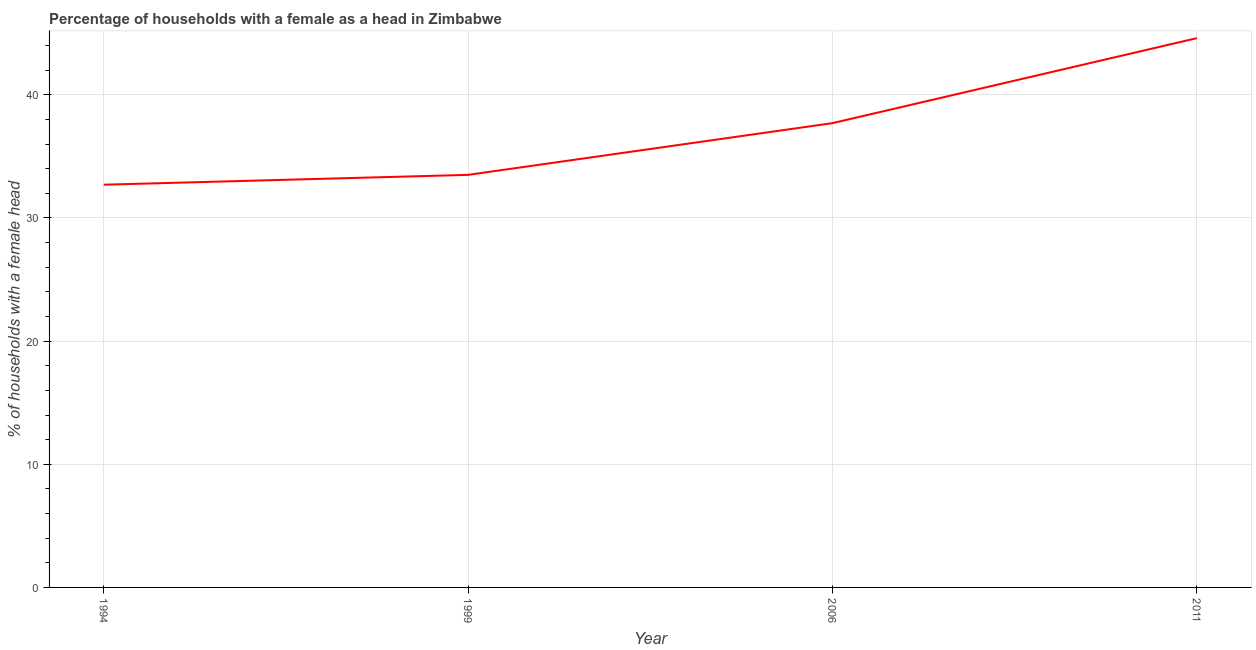What is the number of female supervised households in 2006?
Your answer should be very brief. 37.7. Across all years, what is the maximum number of female supervised households?
Provide a succinct answer. 44.6. Across all years, what is the minimum number of female supervised households?
Offer a very short reply. 32.7. In which year was the number of female supervised households maximum?
Provide a short and direct response. 2011. In which year was the number of female supervised households minimum?
Keep it short and to the point. 1994. What is the sum of the number of female supervised households?
Give a very brief answer. 148.5. What is the difference between the number of female supervised households in 1994 and 2011?
Provide a succinct answer. -11.9. What is the average number of female supervised households per year?
Make the answer very short. 37.12. What is the median number of female supervised households?
Ensure brevity in your answer.  35.6. What is the ratio of the number of female supervised households in 1994 to that in 2011?
Your answer should be very brief. 0.73. What is the difference between the highest and the second highest number of female supervised households?
Give a very brief answer. 6.9. Is the sum of the number of female supervised households in 1994 and 1999 greater than the maximum number of female supervised households across all years?
Offer a very short reply. Yes. What is the difference between the highest and the lowest number of female supervised households?
Offer a terse response. 11.9. Does the number of female supervised households monotonically increase over the years?
Make the answer very short. Yes. How many lines are there?
Offer a very short reply. 1. What is the difference between two consecutive major ticks on the Y-axis?
Provide a succinct answer. 10. Does the graph contain grids?
Offer a terse response. Yes. What is the title of the graph?
Offer a very short reply. Percentage of households with a female as a head in Zimbabwe. What is the label or title of the X-axis?
Your answer should be very brief. Year. What is the label or title of the Y-axis?
Give a very brief answer. % of households with a female head. What is the % of households with a female head in 1994?
Offer a very short reply. 32.7. What is the % of households with a female head in 1999?
Give a very brief answer. 33.5. What is the % of households with a female head of 2006?
Your answer should be compact. 37.7. What is the % of households with a female head of 2011?
Provide a short and direct response. 44.6. What is the difference between the % of households with a female head in 1994 and 2006?
Offer a very short reply. -5. What is the difference between the % of households with a female head in 1999 and 2006?
Offer a very short reply. -4.2. What is the difference between the % of households with a female head in 1999 and 2011?
Keep it short and to the point. -11.1. What is the ratio of the % of households with a female head in 1994 to that in 2006?
Provide a succinct answer. 0.87. What is the ratio of the % of households with a female head in 1994 to that in 2011?
Your answer should be compact. 0.73. What is the ratio of the % of households with a female head in 1999 to that in 2006?
Your response must be concise. 0.89. What is the ratio of the % of households with a female head in 1999 to that in 2011?
Your response must be concise. 0.75. What is the ratio of the % of households with a female head in 2006 to that in 2011?
Your response must be concise. 0.84. 